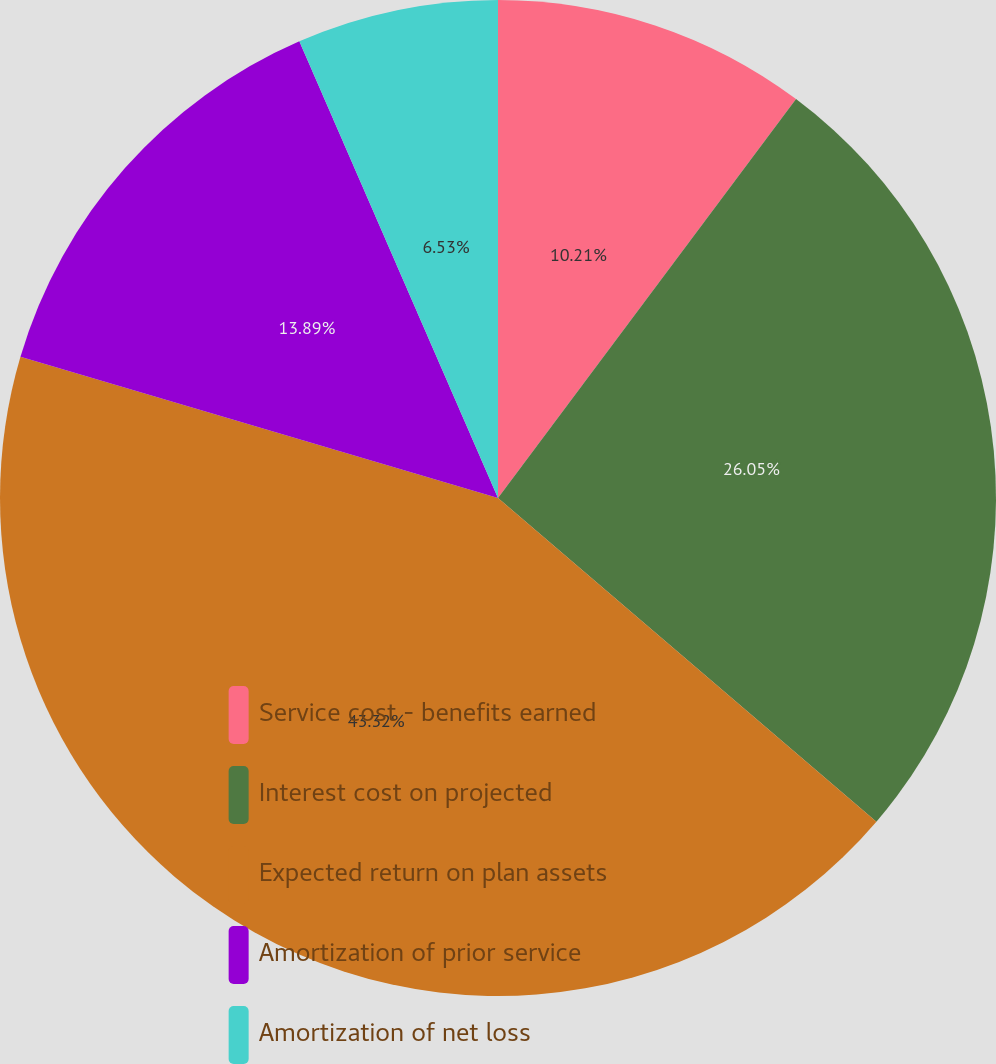<chart> <loc_0><loc_0><loc_500><loc_500><pie_chart><fcel>Service cost - benefits earned<fcel>Interest cost on projected<fcel>Expected return on plan assets<fcel>Amortization of prior service<fcel>Amortization of net loss<nl><fcel>10.21%<fcel>26.05%<fcel>43.31%<fcel>13.89%<fcel>6.53%<nl></chart> 